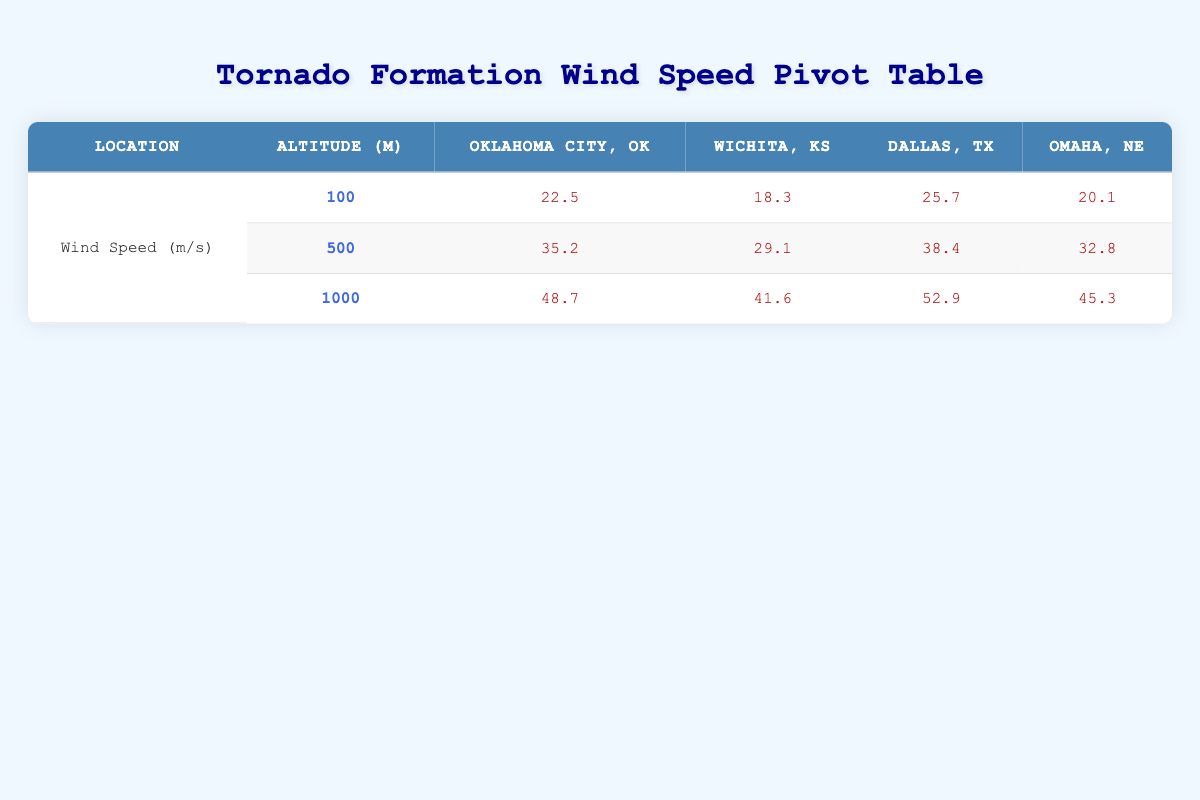What is the wind speed at 100 meters altitude in Oklahoma City? Referring to the table, under the Oklahoma City row and the 100 meters altitude, the wind speed is 22.5 m/s.
Answer: 22.5 m/s What is the maximum wind speed recorded at 500 meters altitude across all locations? The maximum wind speeds at 500 meters can be found from each location: Oklahoma City (35.2 m/s), Wichita (29.1 m/s), Dallas (38.4 m/s), and Omaha (32.8 m/s). The highest value is 38.4 m/s in Dallas.
Answer: 38.4 m/s Is the wind speed at 1000 meters altitude in Wichita greater than that in Oklahoma City? In Wichita, the wind speed at 1000 meters is 41.6 m/s and in Oklahoma City, it is 48.7 m/s. Since 41.6 m/s is less than 48.7 m/s, the statement is false.
Answer: No What was the average wind speed across all locations at 100 meters altitude during tornado formation? The wind speeds at 100 meters for each location are: 22.5 m/s (OKC), 18.3 m/s (Wichita), 25.7 m/s (Dallas), and 20.1 m/s (Omaha). Summing these gives (22.5 + 18.3 + 25.7 + 20.1) = 86.6 m/s. The average is 86.6 / 4 = 21.65 m/s.
Answer: 21.65 m/s At which altitude is the wind speed highest in Dallas? Looking at the Dallas entries: 100 m (25.7 m/s), 500 m (38.4 m/s), and 1000 m (52.9 m/s), it shows that the highest wind speed is at 1000 m.
Answer: 1000 meters Which measurement device recorded the highest wind speed and at what altitude? The highest wind speed is 52.9 m/s recorded in Dallas at 1000 meters altitude, using the Weather Balloon device.
Answer: 52.9 m/s at 1000 meters (Weather Balloon) Was the wind speed at 500 meters in Omaha greater than that in Wichita? Between the measures, the wind speed at 500 meters in Omaha is 32.8 m/s, while in Wichita, it is 29.1 m/s. Since 32.8 m/s is greater than 29.1 m/s, the statement is true.
Answer: Yes What is the difference in wind speed at 1000 meters between the highest and lowest values across locations? The highest wind speed at 1000 meters is 52.9 m/s in Dallas and the lowest is 41.6 m/s in Wichita. The difference is 52.9 m/s - 41.6 m/s = 11.3 m/s.
Answer: 11.3 m/s 